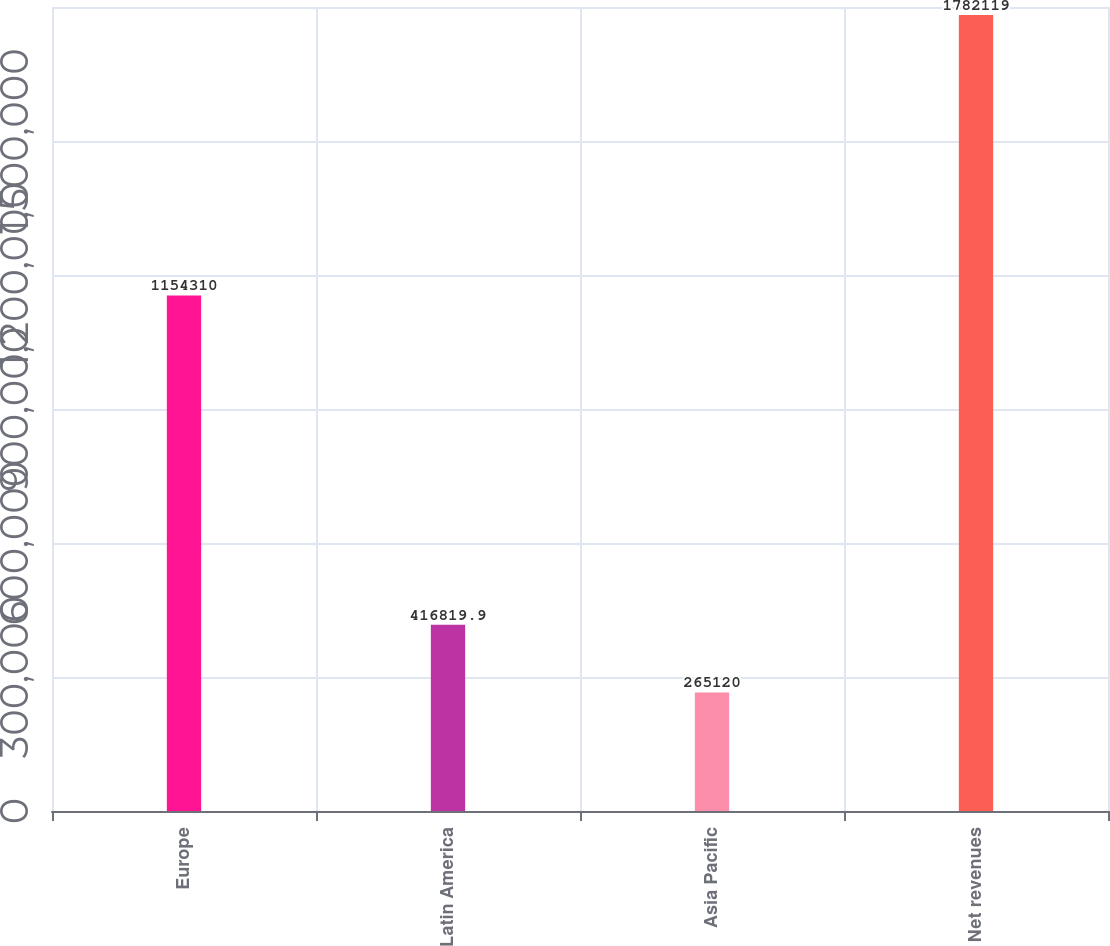Convert chart. <chart><loc_0><loc_0><loc_500><loc_500><bar_chart><fcel>Europe<fcel>Latin America<fcel>Asia Pacific<fcel>Net revenues<nl><fcel>1.15431e+06<fcel>416820<fcel>265120<fcel>1.78212e+06<nl></chart> 